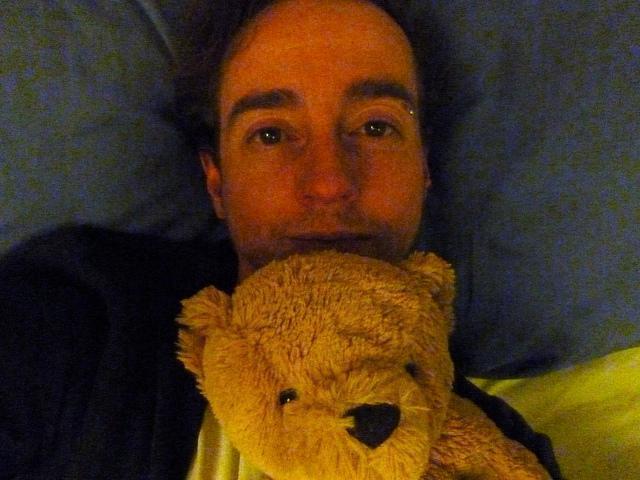Is "The person is above the teddy bear." an appropriate description for the image?
Answer yes or no. No. 